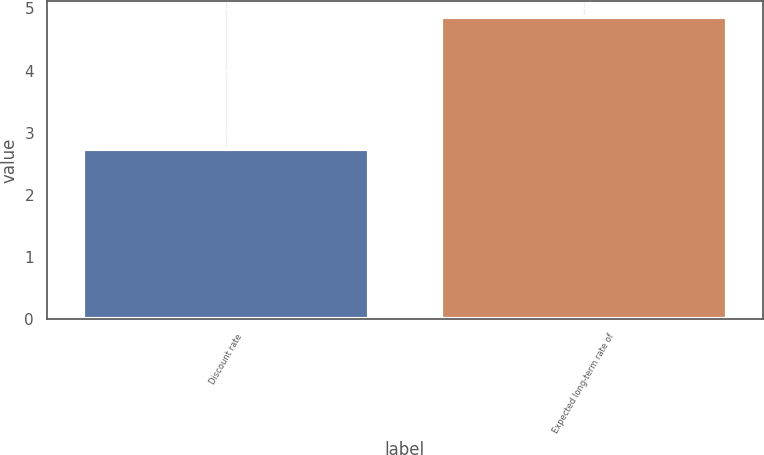Convert chart to OTSL. <chart><loc_0><loc_0><loc_500><loc_500><bar_chart><fcel>Discount rate<fcel>Expected long-term rate of<nl><fcel>2.73<fcel>4.87<nl></chart> 